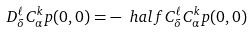<formula> <loc_0><loc_0><loc_500><loc_500>D _ { \delta } ^ { \ell } C _ { \alpha } ^ { k } p ( 0 , 0 ) = - \ h a l f C _ { \delta } ^ { \ell } C _ { \alpha } ^ { k } p ( 0 , 0 )</formula> 